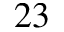Convert formula to latex. <formula><loc_0><loc_0><loc_500><loc_500>^ { 2 3 }</formula> 